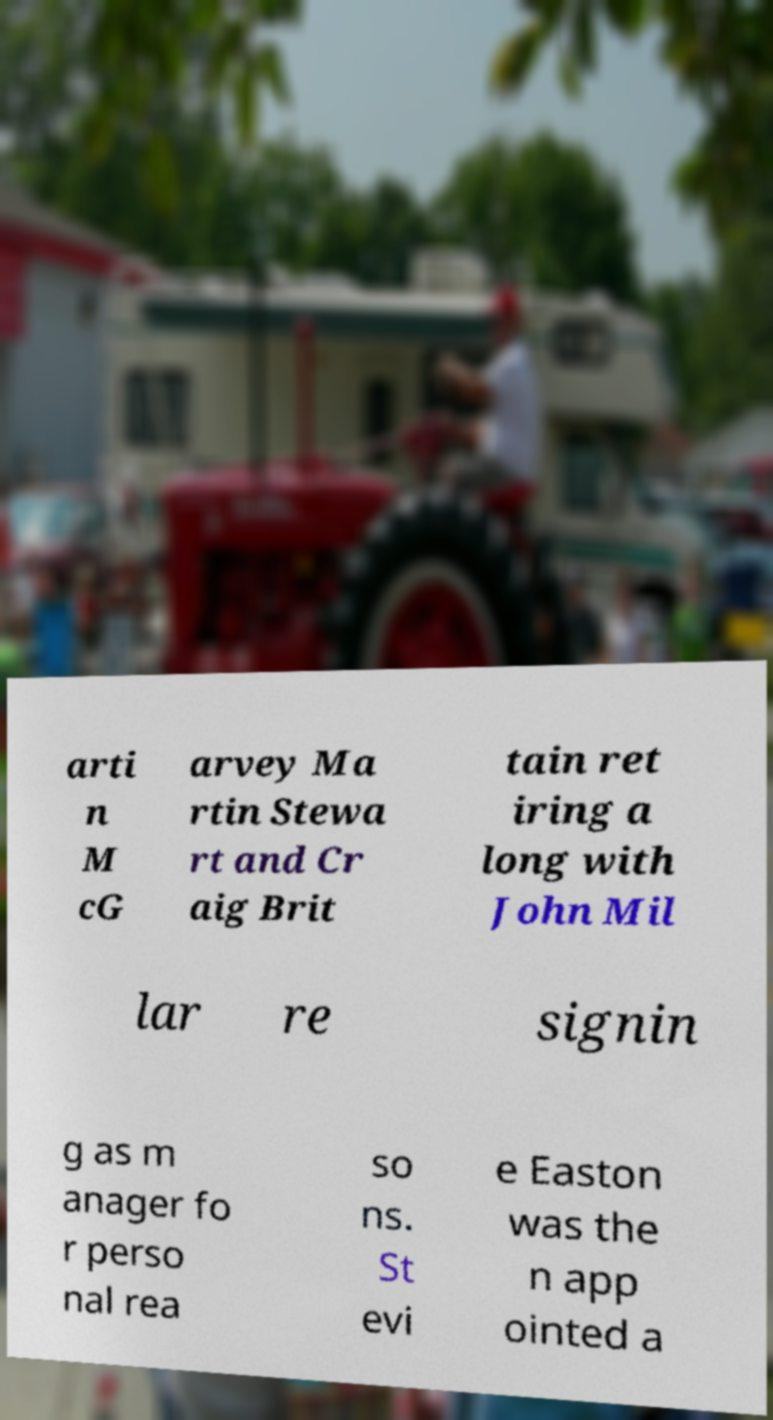Can you accurately transcribe the text from the provided image for me? arti n M cG arvey Ma rtin Stewa rt and Cr aig Brit tain ret iring a long with John Mil lar re signin g as m anager fo r perso nal rea so ns. St evi e Easton was the n app ointed a 